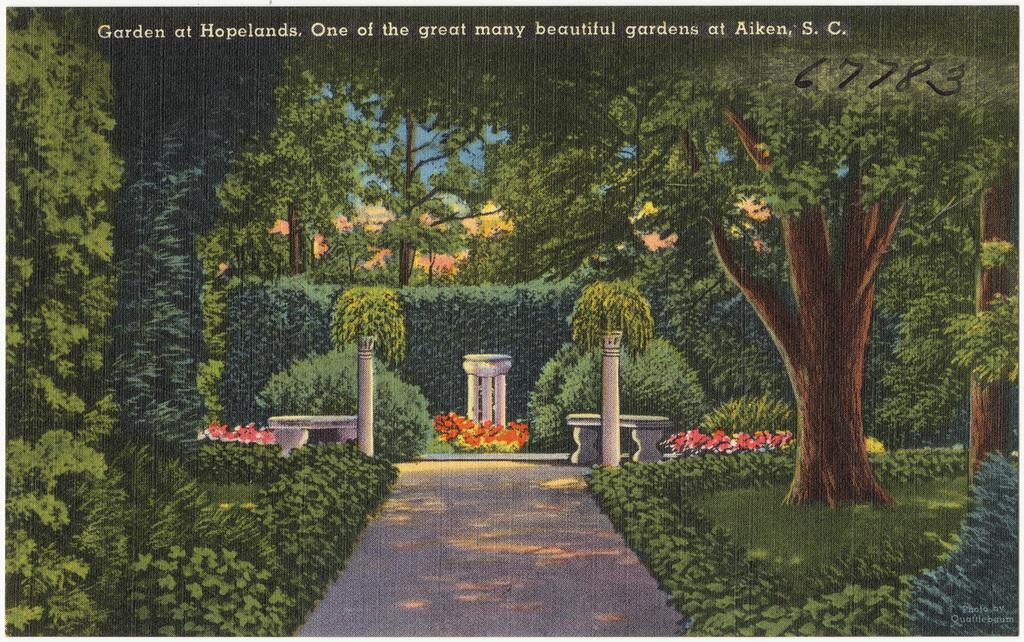What is the main subject of the image? There is a painting in the image. What elements are present in the painting? The painting contains trees, plants, bushes, pillars, and text. How many tickets can be seen in the painting? There are no tickets present in the painting; it contains trees, plants, bushes, pillars, and text. 